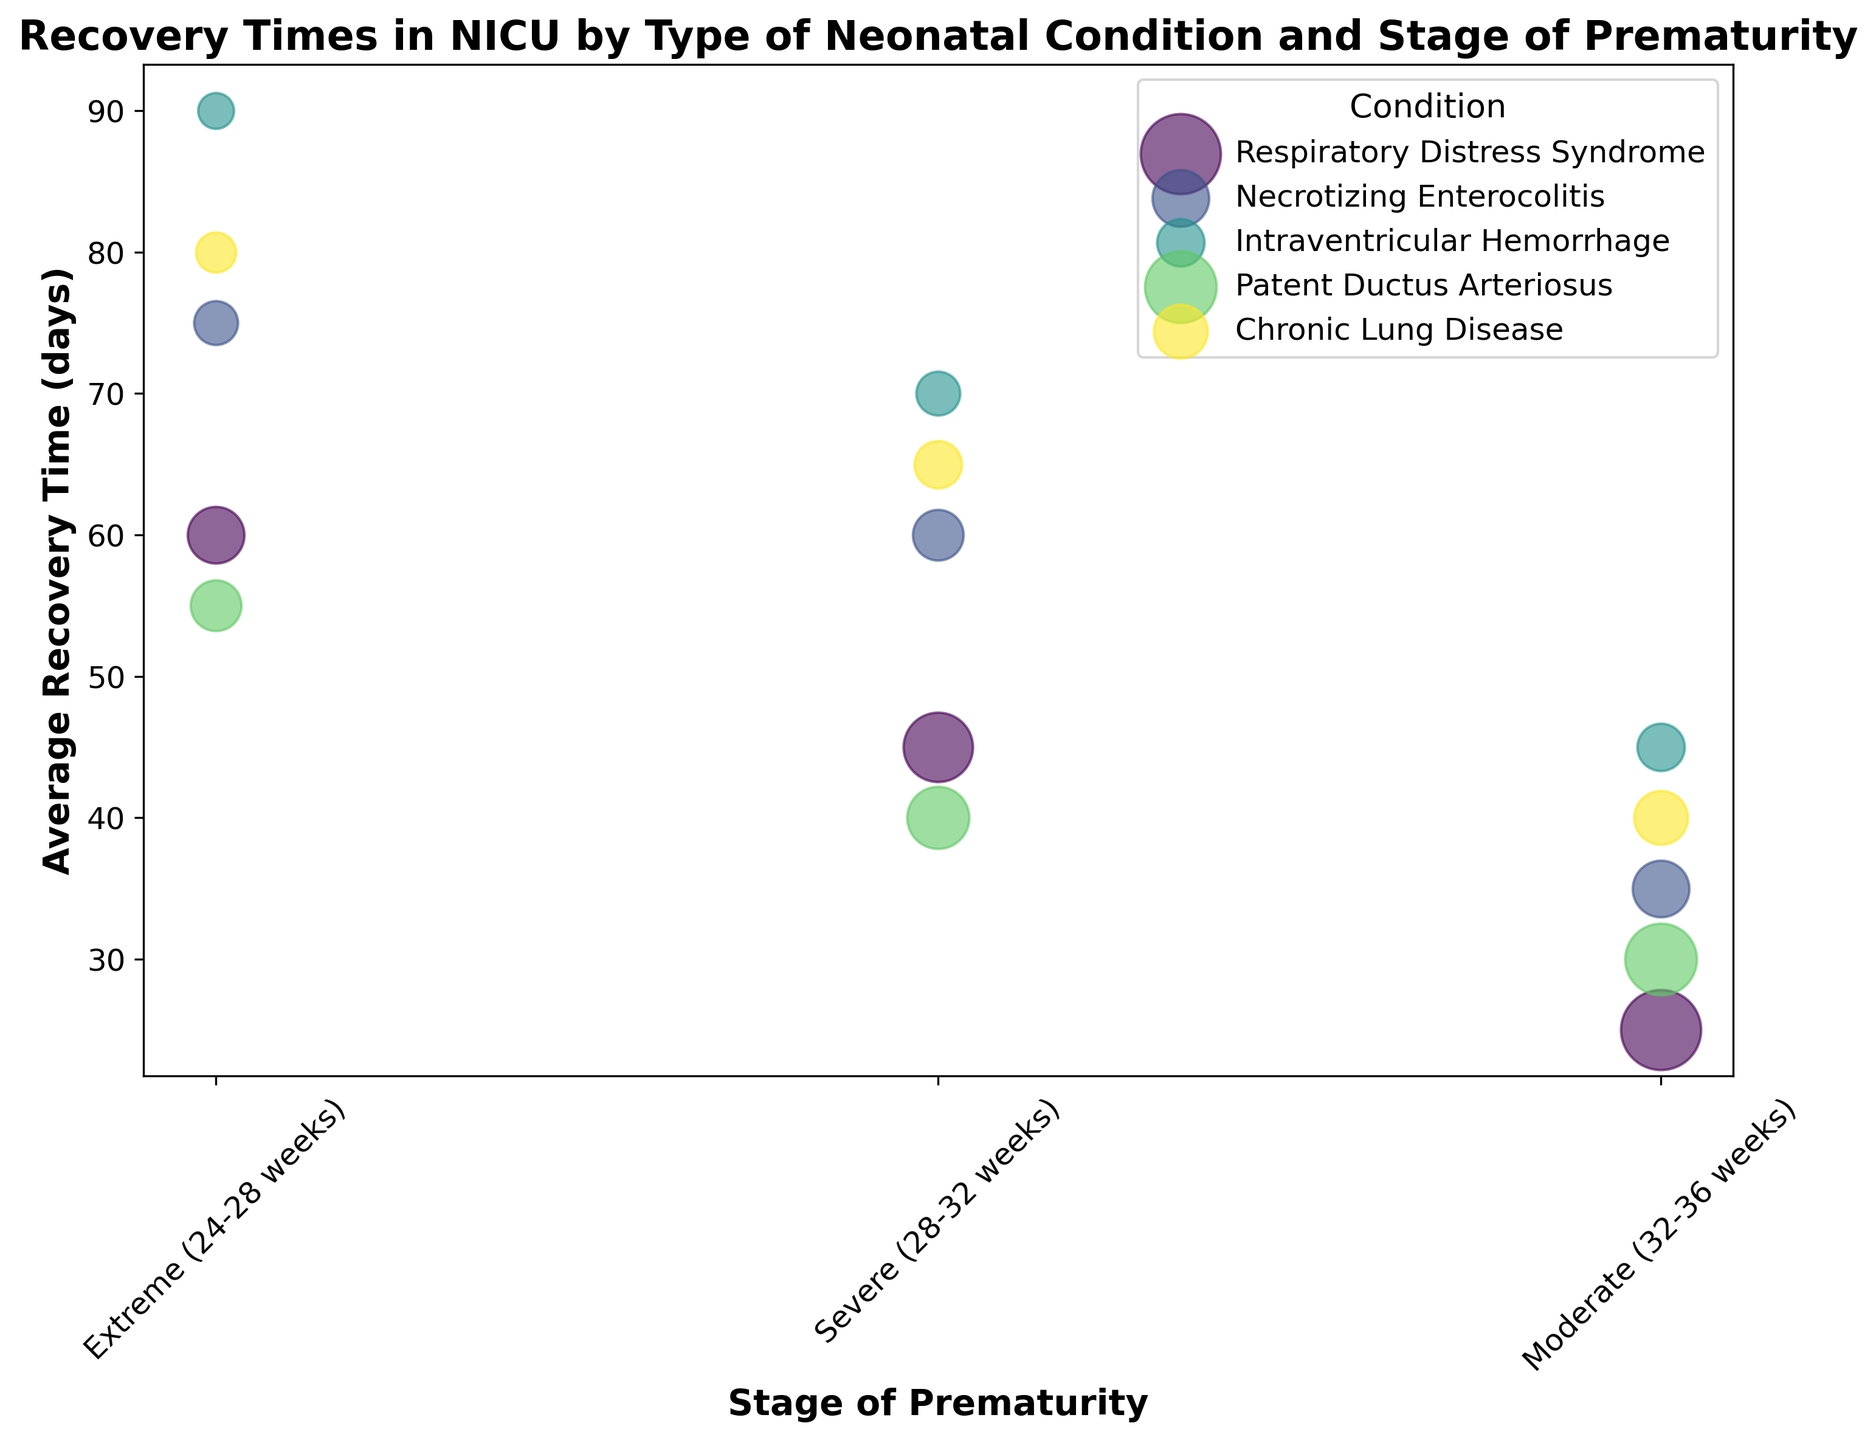What condition has the largest average recovery time for the 'Extreme (24-28 weeks)' stage of prematurity? The figure shows the average recovery time by condition for different stages. We look at the 'Extreme (24-28 weeks)' bubbles and see which one is highest. The largest bubble for this stage is Intraventricular Hemorrhage with 90 days.
Answer: Intraventricular Hemorrhage What is the total number of cases for Respiratory Distress Syndrome across all stages of prematurity? To find the total, sum the number of cases for Respiratory Distress Syndrome from all stages: 50 (Extreme) + 75 (Severe) + 100 (Moderate) = 225.
Answer: 225 Which condition has the smallest average recovery time for the 'Moderate (32-36 weeks)' stage of prematurity? Look at the 'Moderate (32-36 weeks)' section of the figure and identify the smallest bubble. The smallest bubble is Respiratory Distress Syndrome with 25 days.
Answer: Respiratory Distress Syndrome How does the average recovery time of Chronic Lung Disease for the 'Severe (28-32 weeks)' stage compare to Patent Ductus Arteriosus for the same stage? Compare the height of the bubbles for Chronic Lung Disease and Patent Ductus Arteriosus in the 'Severe (28-32 weeks)' stage. Chronic Lung Disease has an average recovery time of 65 days and Patent Ductus Arteriosus has 40 days. Chronic Lung Disease is greater.
Answer: Greater What is the average recovery time difference between Necrotizing Enterocolitis and Patent Ductus Arteriosus in the 'Extreme (24-28 weeks)' stage? Subtract the average recovery time of Patent Ductus Arteriosus from Necrotizing Enterocolitis in the 'Extreme (24-28 weeks)' stage: 75 (Necrotizing Enterocolitis) - 55 (Patent Ductus Arteriosus) = 20.
Answer: 20 How many more cases of Respiratory Distress Syndrome are there in the 'Moderate (32-36 weeks)' stage compared to the 'Extreme (24-28 weeks)' stage? Subtract the number of cases of Respiratory Distress Syndrome in 'Extreme (24-28 weeks)' from 'Moderate (32-36 weeks)': 100 (Moderate) - 50 (Extreme) = 50.
Answer: 50 Which stage of prematurity shows the highest average recovery time for Chronic Lung Disease? Look at the bubbles for Chronic Lung Disease across all stages and identify the stage with the highest bubble. The highest bubble is in the 'Extreme (24-28 weeks)' stage with 80 days.
Answer: 'Extreme (24-28 weeks)' Compare the average recovery times of Intraventricular Hemorrhage and Necrotizing Enterocolitis in the 'Severe (28-32 weeks)' stage. Which one is higher? Find the bubbles for Intraventricular Hemorrhage and Necrotizing Enterocolitis in the 'Severe (28-32 weeks)' stage. Intraventricular Hemorrhage has 70 days and Necrotizing Enterocolitis has 60 days. Intraventricular Hemorrhage is higher.
Answer: Intraventricular Hemorrhage Which condition has the largest number of cases in the 'Moderate (32-36 weeks)' stage? Identify the largest bubble in the 'Moderate (32-36 weeks)' stage section. The largest bubble is Respiratory Distress Syndrome with 100 cases.
Answer: Respiratory Distress Syndrome 